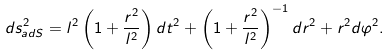<formula> <loc_0><loc_0><loc_500><loc_500>d s _ { a d S } ^ { 2 } = l ^ { 2 } \left ( 1 + \frac { r ^ { 2 } } { l ^ { 2 } } \right ) d t ^ { 2 } + \left ( 1 + \frac { r ^ { 2 } } { l ^ { 2 } } \right ) ^ { - 1 } d r ^ { 2 } + r ^ { 2 } d \varphi ^ { 2 } .</formula> 